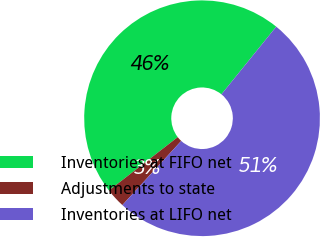Convert chart to OTSL. <chart><loc_0><loc_0><loc_500><loc_500><pie_chart><fcel>Inventories at FIFO net<fcel>Adjustments to state<fcel>Inventories at LIFO net<nl><fcel>46.34%<fcel>2.68%<fcel>50.98%<nl></chart> 